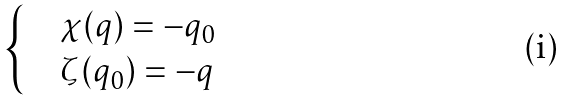<formula> <loc_0><loc_0><loc_500><loc_500>\begin{cases} & \chi ( q ) = - q _ { 0 } \\ & \zeta ( q _ { 0 } ) = - q \end{cases}</formula> 